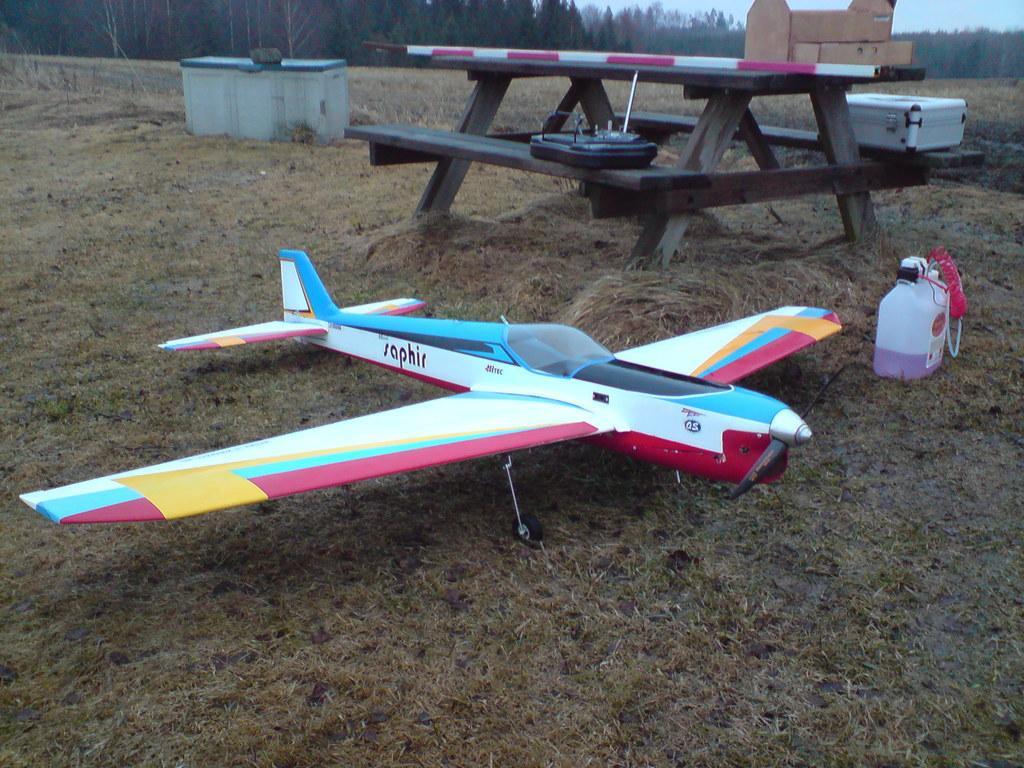Please provide a concise description of this image. In this image there is a toy of an airplane. There is a can. There is a wooden table. On top of it there are some objects. Behind the table there is another table. On top of it there is some object. In the background of the image there are trees and sky. 